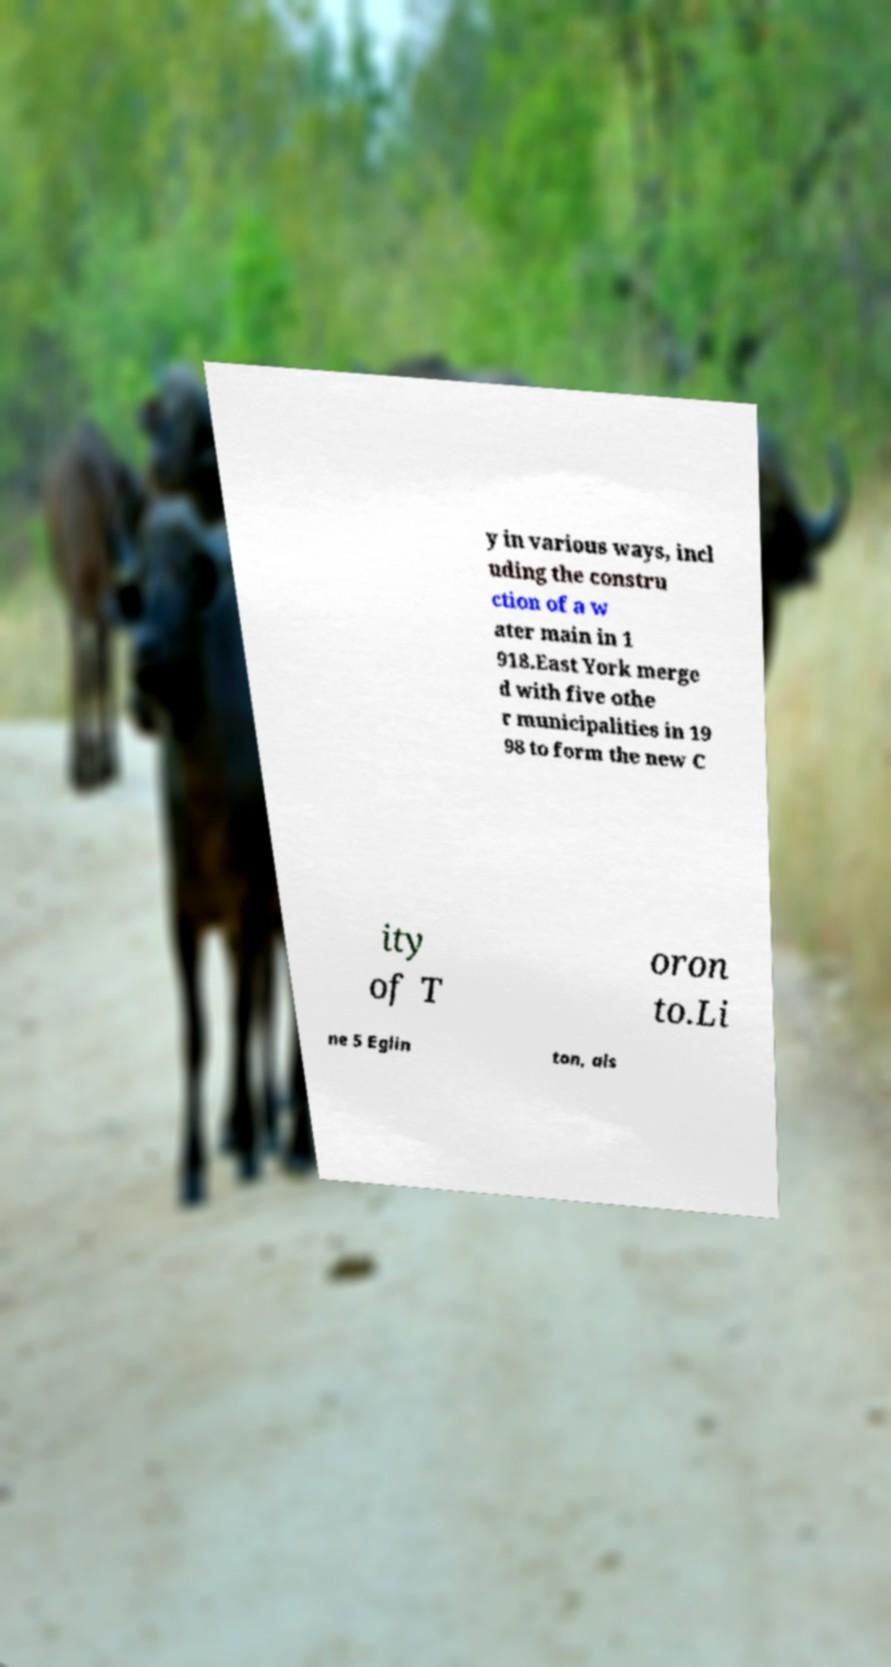Could you extract and type out the text from this image? y in various ways, incl uding the constru ction of a w ater main in 1 918.East York merge d with five othe r municipalities in 19 98 to form the new C ity of T oron to.Li ne 5 Eglin ton, als 